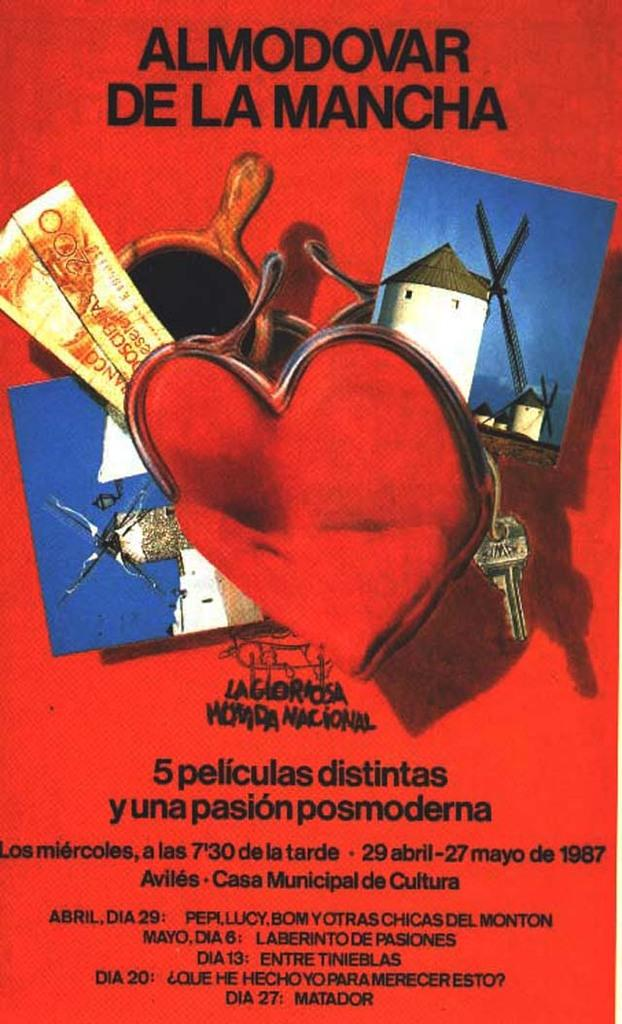<image>
Render a clear and concise summary of the photo. a poster with the title Almond De La Mancha 